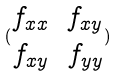Convert formula to latex. <formula><loc_0><loc_0><loc_500><loc_500>( \begin{matrix} f _ { x x } & f _ { x y } \\ f _ { x y } & f _ { y y } \end{matrix} )</formula> 